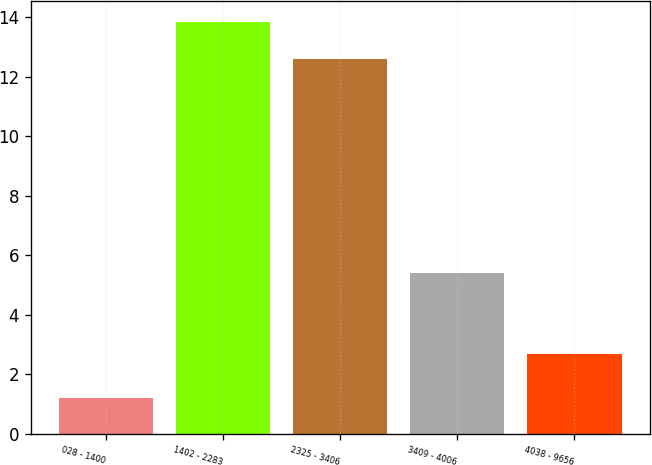Convert chart. <chart><loc_0><loc_0><loc_500><loc_500><bar_chart><fcel>028 - 1400<fcel>1402 - 2283<fcel>2325 - 3406<fcel>3409 - 4006<fcel>4038 - 9656<nl><fcel>1.2<fcel>13.85<fcel>12.6<fcel>5.4<fcel>2.7<nl></chart> 